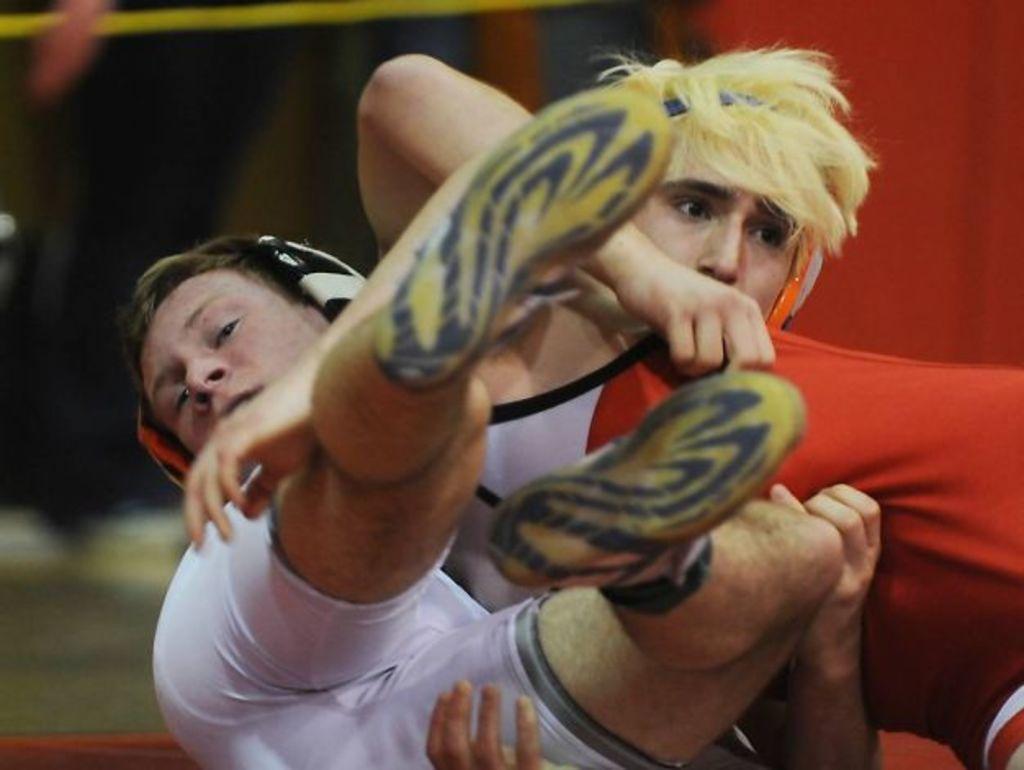In one or two sentences, can you explain what this image depicts? In the image we can see two persons are sitting and holding. 